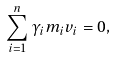Convert formula to latex. <formula><loc_0><loc_0><loc_500><loc_500>\sum _ { i = 1 } ^ { n } \gamma _ { i } m _ { i } v _ { i } = 0 ,</formula> 